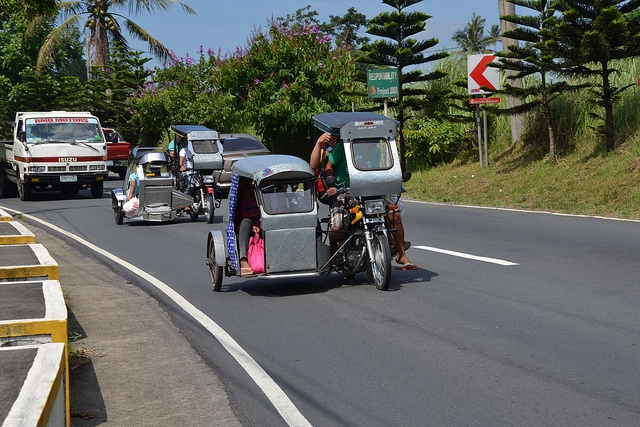Describe the objects in this image and their specific colors. I can see truck in darkgreen, lightgray, black, gray, and darkgray tones, motorcycle in darkgreen, black, gray, darkgray, and lightgray tones, car in darkgreen, gray, black, and darkgray tones, truck in darkgreen, black, maroon, gray, and darkgray tones, and people in darkgreen, black, gray, brown, and lightpink tones in this image. 